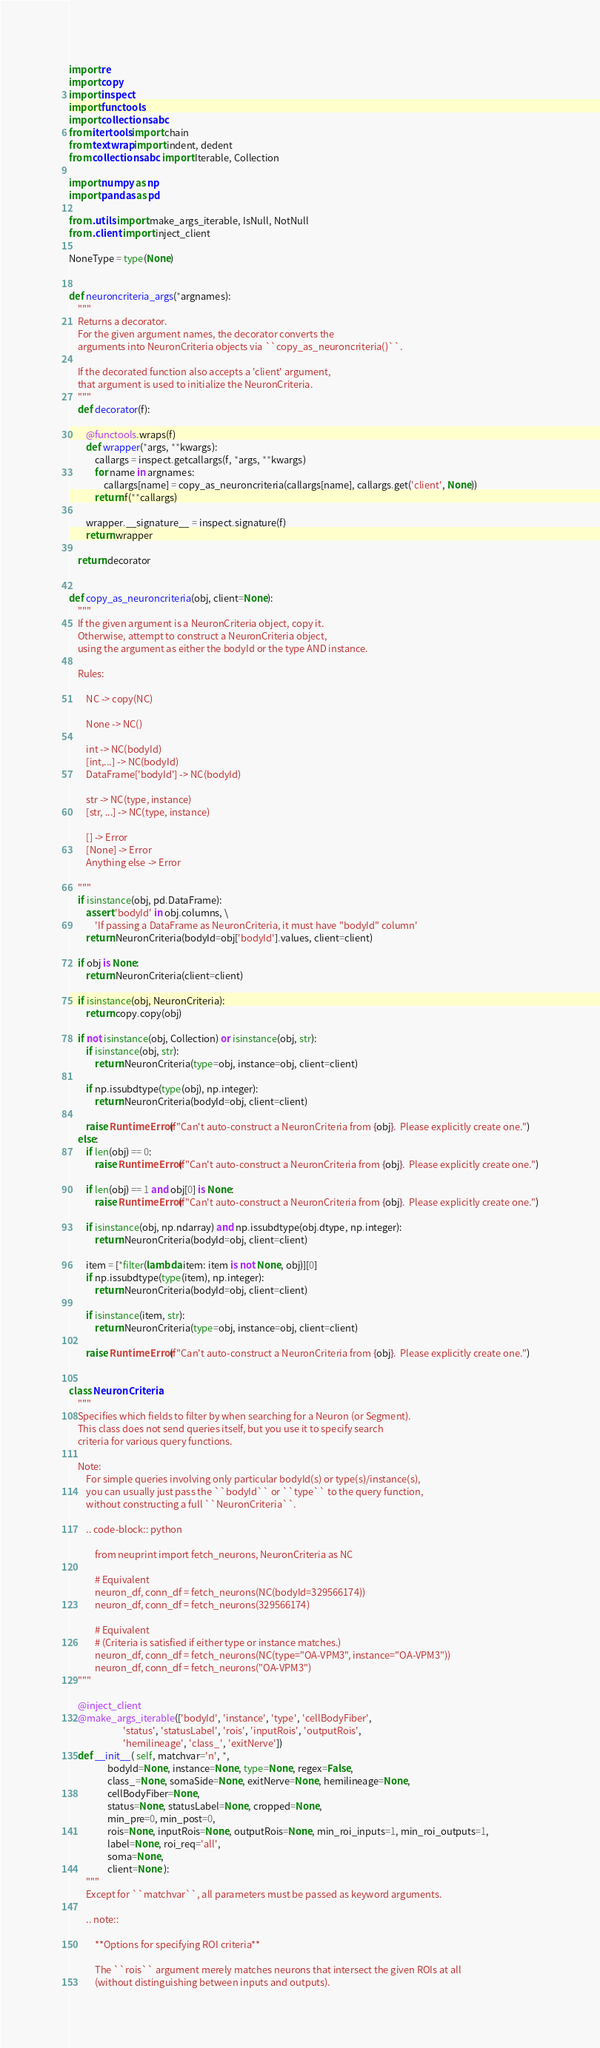<code> <loc_0><loc_0><loc_500><loc_500><_Python_>import re
import copy
import inspect
import functools
import collections.abc
from itertools import chain
from textwrap import indent, dedent
from collections.abc import Iterable, Collection

import numpy as np
import pandas as pd

from .utils import make_args_iterable, IsNull, NotNull
from .client import inject_client

NoneType = type(None)


def neuroncriteria_args(*argnames):
    """
    Returns a decorator.
    For the given argument names, the decorator converts the
    arguments into NeuronCriteria objects via ``copy_as_neuroncriteria()``.

    If the decorated function also accepts a 'client' argument,
    that argument is used to initialize the NeuronCriteria.
    """
    def decorator(f):

        @functools.wraps(f)
        def wrapper(*args, **kwargs):
            callargs = inspect.getcallargs(f, *args, **kwargs)
            for name in argnames:
                callargs[name] = copy_as_neuroncriteria(callargs[name], callargs.get('client', None))
            return f(**callargs)

        wrapper.__signature__ = inspect.signature(f)
        return wrapper

    return decorator


def copy_as_neuroncriteria(obj, client=None):
    """
    If the given argument is a NeuronCriteria object, copy it.
    Otherwise, attempt to construct a NeuronCriteria object,
    using the argument as either the bodyId or the type AND instance.

    Rules:

        NC -> copy(NC)

        None -> NC()

        int -> NC(bodyId)
        [int,...] -> NC(bodyId)
        DataFrame['bodyId'] -> NC(bodyId)

        str -> NC(type, instance)
        [str, ...] -> NC(type, instance)

        [] -> Error
        [None] -> Error
        Anything else -> Error

    """
    if isinstance(obj, pd.DataFrame):
        assert 'bodyId' in obj.columns, \
            'If passing a DataFrame as NeuronCriteria, it must have "bodyId" column'
        return NeuronCriteria(bodyId=obj['bodyId'].values, client=client)

    if obj is None:
        return NeuronCriteria(client=client)

    if isinstance(obj, NeuronCriteria):
        return copy.copy(obj)

    if not isinstance(obj, Collection) or isinstance(obj, str):
        if isinstance(obj, str):
            return NeuronCriteria(type=obj, instance=obj, client=client)

        if np.issubdtype(type(obj), np.integer):
            return NeuronCriteria(bodyId=obj, client=client)

        raise RuntimeError(f"Can't auto-construct a NeuronCriteria from {obj}.  Please explicitly create one.")
    else:
        if len(obj) == 0:
            raise RuntimeError(f"Can't auto-construct a NeuronCriteria from {obj}.  Please explicitly create one.")

        if len(obj) == 1 and obj[0] is None:
            raise RuntimeError(f"Can't auto-construct a NeuronCriteria from {obj}.  Please explicitly create one.")

        if isinstance(obj, np.ndarray) and np.issubdtype(obj.dtype, np.integer):
            return NeuronCriteria(bodyId=obj, client=client)

        item = [*filter(lambda item: item is not None, obj)][0]
        if np.issubdtype(type(item), np.integer):
            return NeuronCriteria(bodyId=obj, client=client)

        if isinstance(item, str):
            return NeuronCriteria(type=obj, instance=obj, client=client)

        raise RuntimeError(f"Can't auto-construct a NeuronCriteria from {obj}.  Please explicitly create one.")


class NeuronCriteria:
    """
    Specifies which fields to filter by when searching for a Neuron (or Segment).
    This class does not send queries itself, but you use it to specify search
    criteria for various query functions.

    Note:
        For simple queries involving only particular bodyId(s) or type(s)/instance(s),
        you can usually just pass the ``bodyId`` or ``type`` to the query function,
        without constructing a full ``NeuronCriteria``.

        .. code-block:: python

            from neuprint import fetch_neurons, NeuronCriteria as NC

            # Equivalent
            neuron_df, conn_df = fetch_neurons(NC(bodyId=329566174))
            neuron_df, conn_df = fetch_neurons(329566174)

            # Equivalent
            # (Criteria is satisfied if either type or instance matches.)
            neuron_df, conn_df = fetch_neurons(NC(type="OA-VPM3", instance="OA-VPM3"))
            neuron_df, conn_df = fetch_neurons("OA-VPM3")
    """

    @inject_client
    @make_args_iterable(['bodyId', 'instance', 'type', 'cellBodyFiber',
                         'status', 'statusLabel', 'rois', 'inputRois', 'outputRois',
                         'hemilineage', 'class_', 'exitNerve'])
    def __init__( self, matchvar='n', *,
                  bodyId=None, instance=None, type=None, regex=False,
                  class_=None, somaSide=None, exitNerve=None, hemilineage=None,
                  cellBodyFiber=None,
                  status=None, statusLabel=None, cropped=None,
                  min_pre=0, min_post=0,
                  rois=None, inputRois=None, outputRois=None, min_roi_inputs=1, min_roi_outputs=1,
                  label=None, roi_req='all',
                  soma=None,
                  client=None ):
        """
        Except for ``matchvar``, all parameters must be passed as keyword arguments.

        .. note::

            **Options for specifying ROI criteria**

            The ``rois`` argument merely matches neurons that intersect the given ROIs at all
            (without distinguishing between inputs and outputs).
</code> 